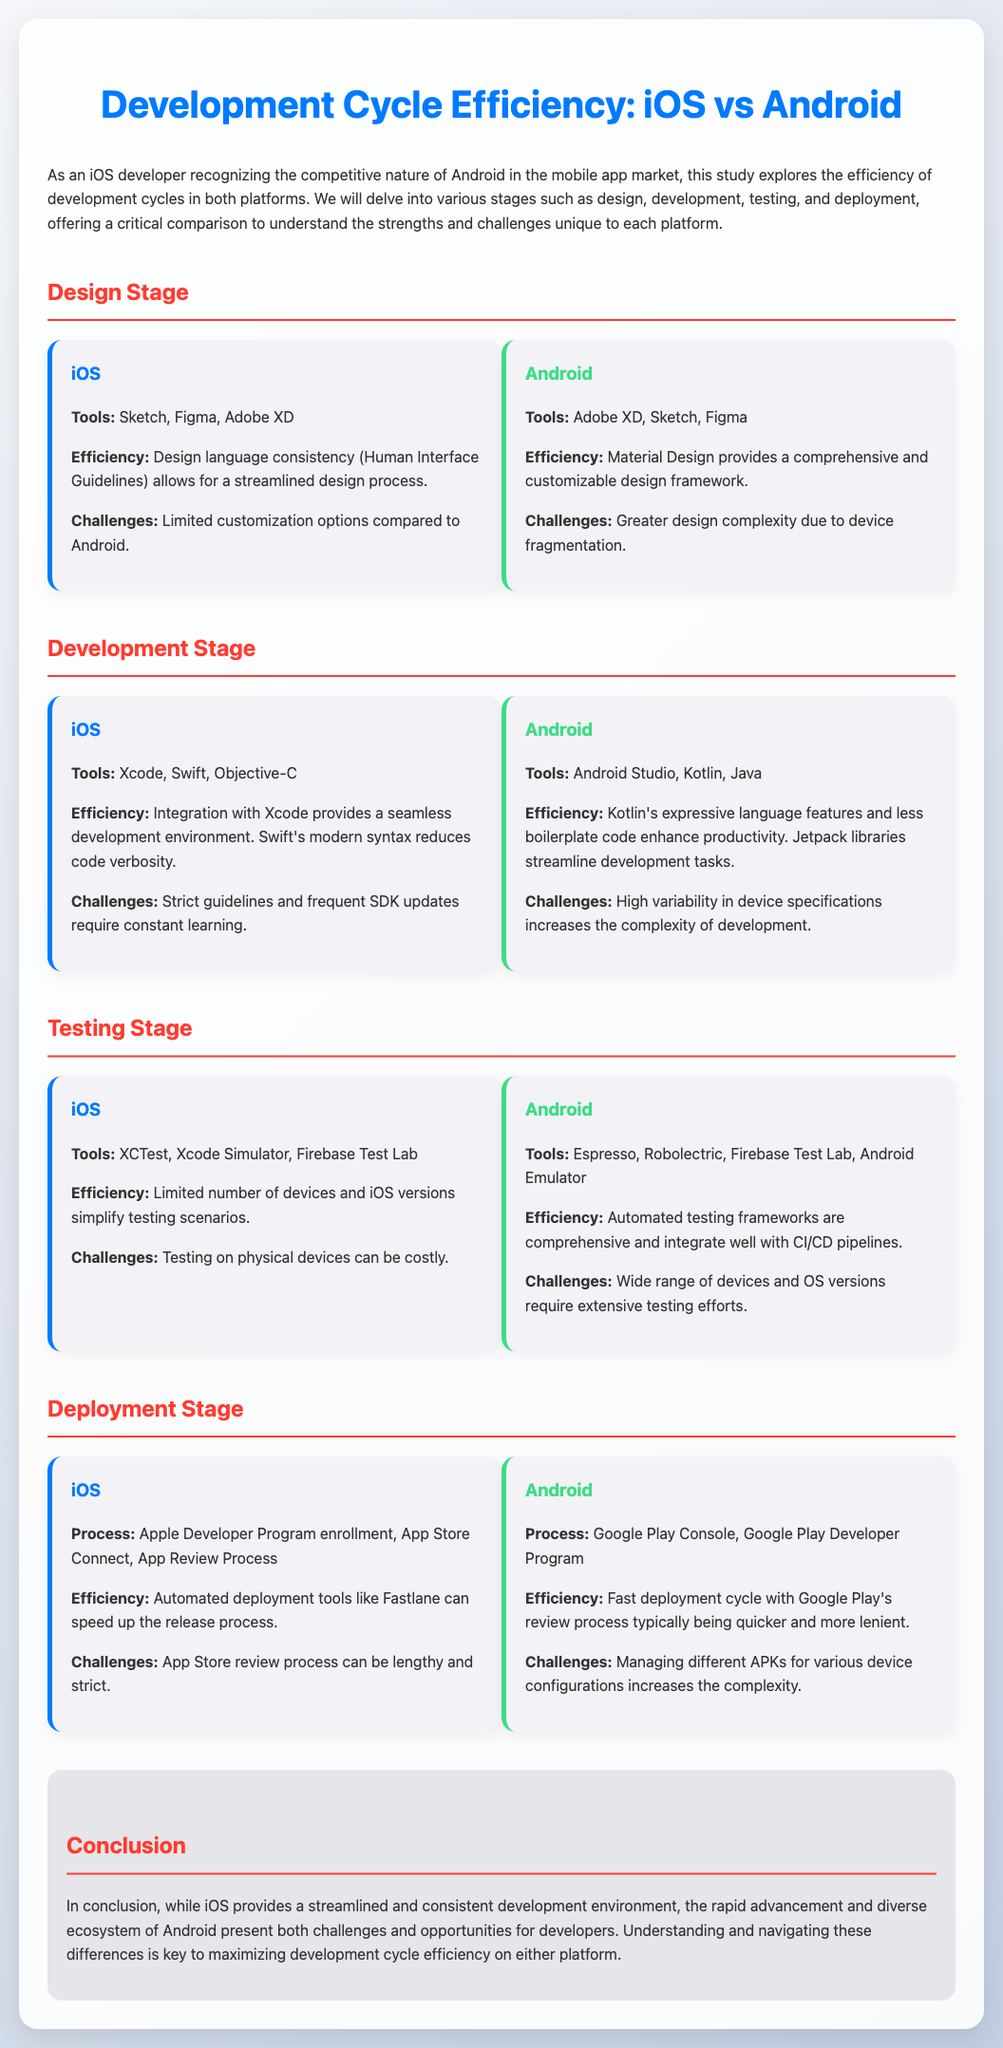What tools are used in the iOS design stage? The document lists Sketch, Figma, and Adobe XD as tools used in the iOS design stage.
Answer: Sketch, Figma, Adobe XD What is a challenge faced in the Android design stage? The document states that greater design complexity due to device fragmentation is a challenge for Android.
Answer: Greater design complexity What efficiency benefit does iOS provide during development? The iOS development section mentions that integration with Xcode provides a seamless development environment.
Answer: Seamless development environment What is the main testing tool for Android? According to the document, Espresso is listed as a main testing tool for Android.
Answer: Espresso How does the iOS deployment process start? The document states that the deployment process starts with Apple Developer Program enrollment.
Answer: Apple Developer Program enrollment What is a challenge mentioned for iOS testing? The document indicates that testing on physical devices can be costly as a challenge for iOS testing.
Answer: Costly testing on physical devices What is the efficiency of Android's deployment process? The document mentions that the deployment cycle is fast with Google's review process being quicker and more lenient.
Answer: Fast deployment cycle What ensures design language consistency in iOS? The document states that Human Interface Guidelines ensure design language consistency in iOS.
Answer: Human Interface Guidelines What does the conclusion imply about the Android ecosystem? The conclusion implies that the diverse ecosystem of Android presents both challenges and opportunities.
Answer: Challenges and opportunities 